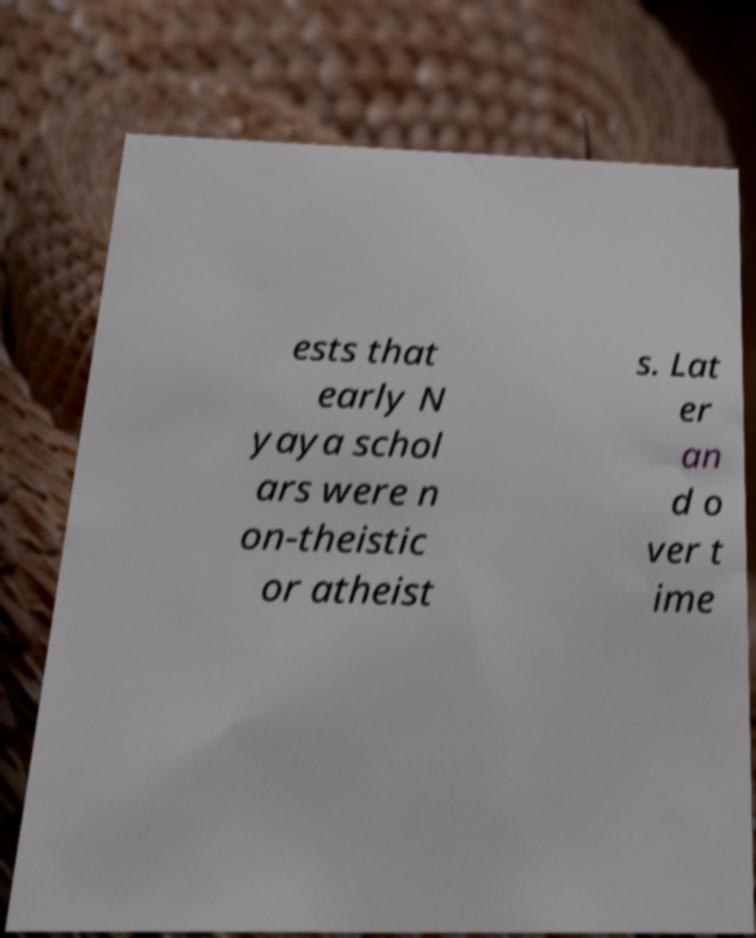Could you assist in decoding the text presented in this image and type it out clearly? ests that early N yaya schol ars were n on-theistic or atheist s. Lat er an d o ver t ime 